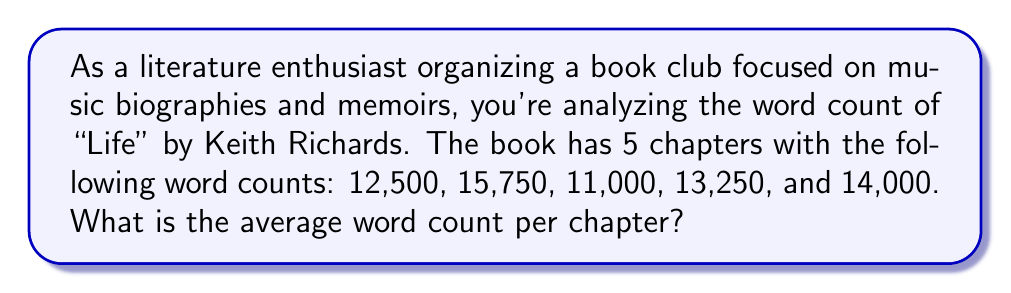Solve this math problem. To find the average word count per chapter, we need to:

1. Sum up the total word count for all chapters
2. Divide the total by the number of chapters

Let's break it down step-by-step:

1. Sum of all chapter word counts:
   $12,500 + 15,750 + 11,000 + 13,250 + 14,000 = 66,500$ words

2. Number of chapters: 5

3. Calculate the average:
   $\text{Average} = \frac{\text{Total word count}}{\text{Number of chapters}}$

   $\text{Average} = \frac{66,500}{5} = 13,300$ words per chapter

Therefore, the average word count per chapter is 13,300 words.
Answer: $13,300$ words per chapter 